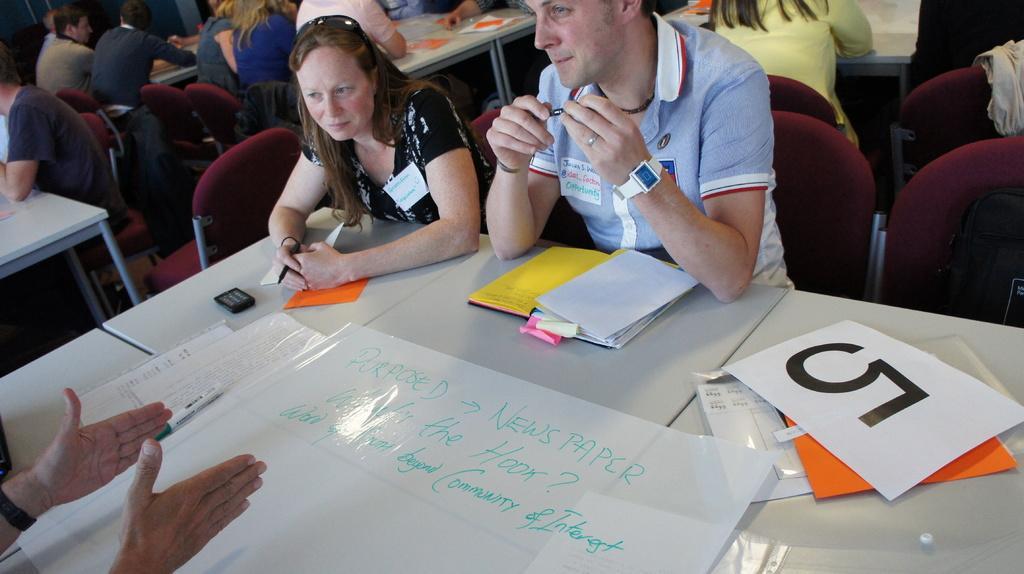Please provide a concise description of this image. This picture describes about group of people, they are seated on the chairs, in front of them we can see few papers, books and other things on the tables. 